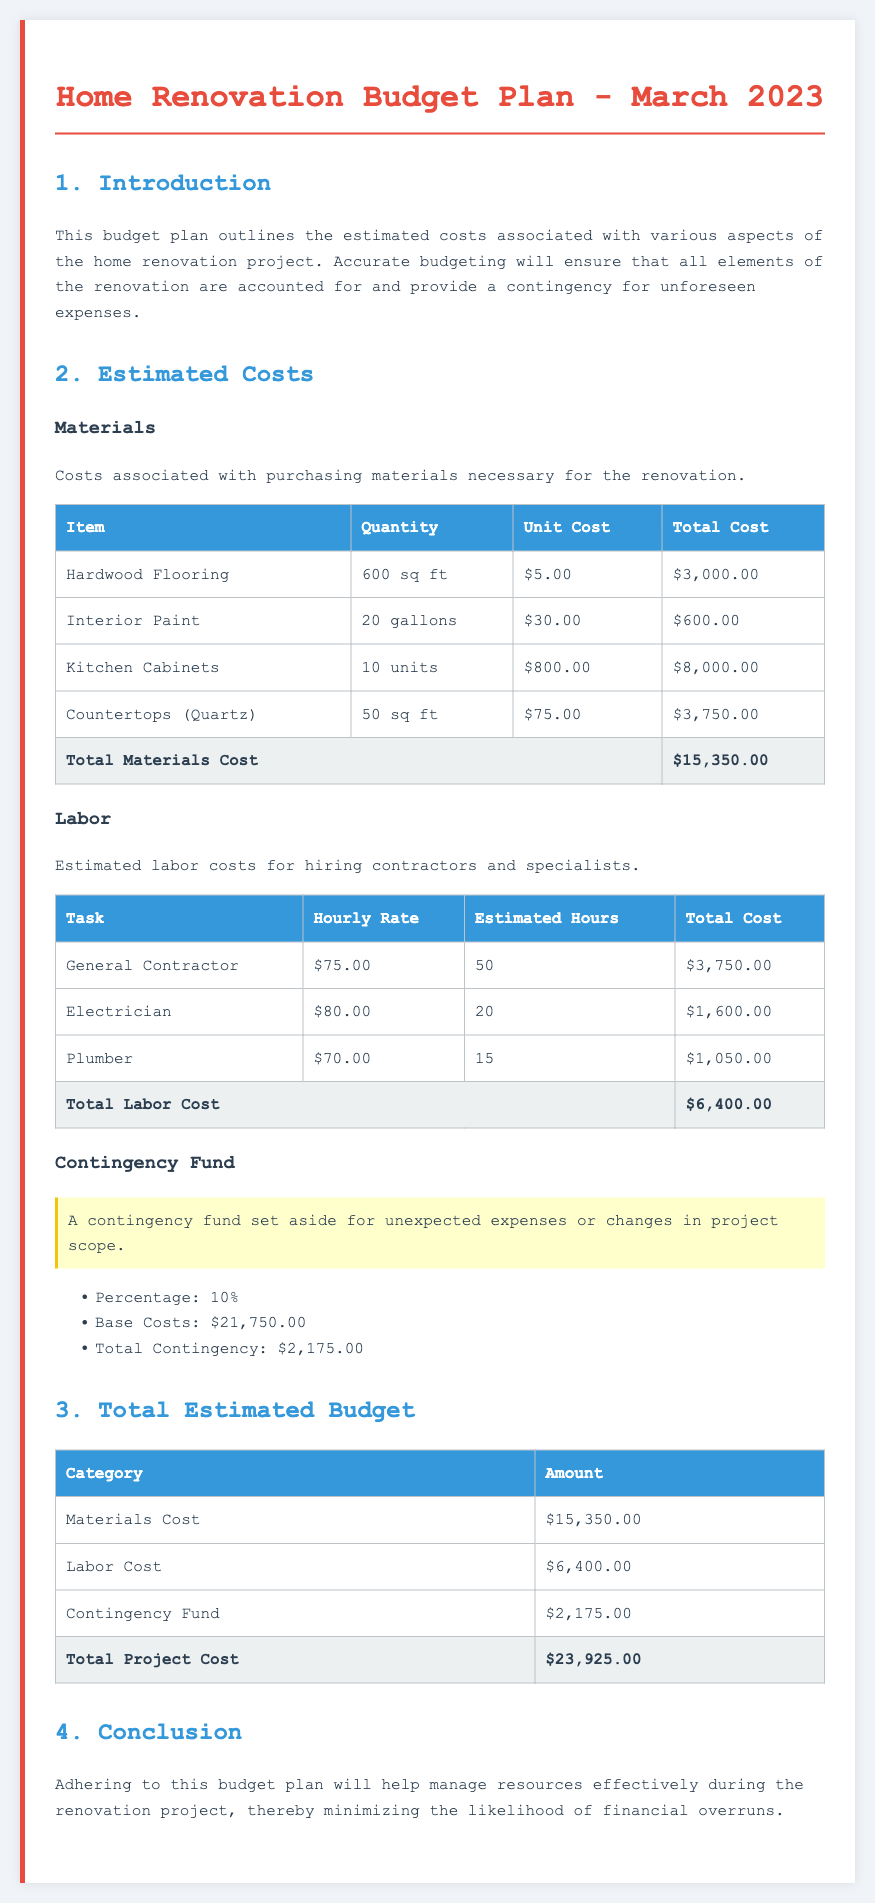What is the total cost of materials? The total cost of materials is calculated from the individual materials' costs listed in the document, resulting in $15,350.00.
Answer: $15,350.00 What is the hourly rate for an electrician? The hourly rate for an electrician is provided in the labor cost section of the document as $80.00.
Answer: $80.00 How many gallons of interior paint are estimated? The estimated quantity of interior paint is stated in the materials section of the document as 20 gallons.
Answer: 20 gallons What is the percentage allocated for the contingency fund? The document specifies that the percentage for the contingency fund is 10%.
Answer: 10% What is the total estimated budget for the project? The total estimated budget is the sum of materials, labor, and contingency costs, which equals $23,925.00.
Answer: $23,925.00 How much is allocated for labor costs? Labor costs are calculated and provided in the budget document as $6,400.00.
Answer: $6,400.00 What is the total contingency amount? The total contingency amount, accounted for unexpected expenses, is stated in the budget as $2,175.00.
Answer: $2,175.00 What is the total number of estimated hours for the plumber? The total estimated hours for the plumber are detailed in the labor section of the document as 15 hours.
Answer: 15 What is the base cost used to calculate the contingency fund? The document indicates that the base costs for the contingency calculation are $21,750.00.
Answer: $21,750.00 